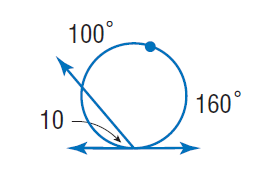Answer the mathemtical geometry problem and directly provide the correct option letter.
Question: Find \angle 10.
Choices: A: 50 B: 80 C: 100 D: 160 A 